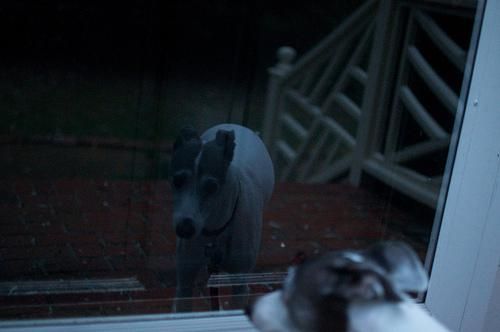Question: what animal is pictured?
Choices:
A. A cat.
B. A bunny.
C. A bird.
D. A dog.
Answer with the letter. Answer: D Question: where is the dog looking?
Choices:
A. The food.
B. The frisbee.
C. The window.
D. The boy.
Answer with the letter. Answer: C Question: what color is the dog?
Choices:
A. Black.
B. Red.
C. Brown.
D. Grey and white.
Answer with the letter. Answer: D Question: what is around the dog's neck?
Choices:
A. A handkerchief.
B. A collar.
C. A leash.
D. A bow.
Answer with the letter. Answer: B Question: how many dogs are pictured?
Choices:
A. Two.
B. One.
C. Three.
D. Four.
Answer with the letter. Answer: A Question: who is in the reflection?
Choices:
A. The cat.
B. The boy.
C. The dog.
D. The girl.
Answer with the letter. Answer: C 